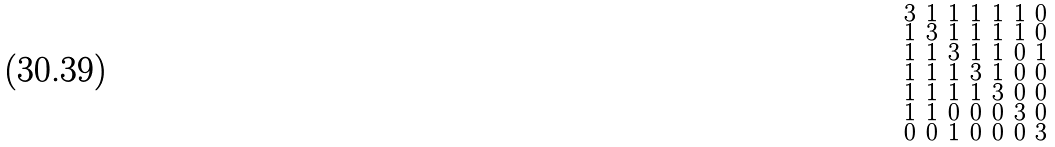<formula> <loc_0><loc_0><loc_500><loc_500>\begin{smallmatrix} 3 & 1 & 1 & 1 & 1 & 1 & 0 \\ 1 & 3 & 1 & 1 & 1 & 1 & 0 \\ 1 & 1 & 3 & 1 & 1 & 0 & 1 \\ 1 & 1 & 1 & 3 & 1 & 0 & 0 \\ 1 & 1 & 1 & 1 & 3 & 0 & 0 \\ 1 & 1 & 0 & 0 & 0 & 3 & 0 \\ 0 & 0 & 1 & 0 & 0 & 0 & 3 \end{smallmatrix}</formula> 